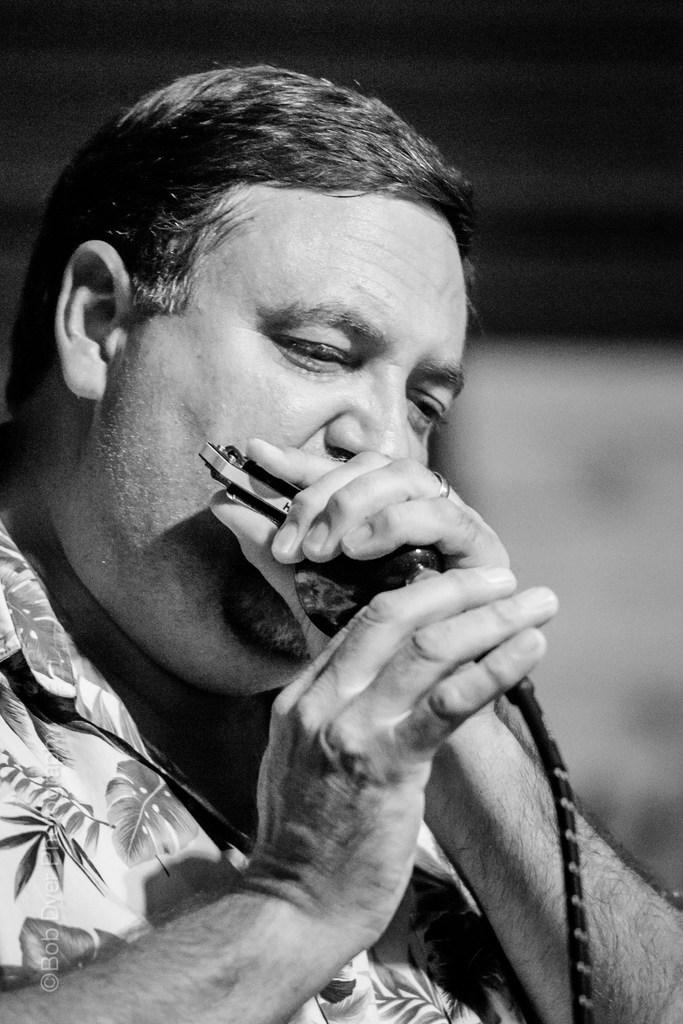What is the color scheme of the image? The image is black and white. Can you describe the main subject of the image? There is a person in the image. What is the person doing in the image? The person is playing a musical instrument with their mouth. What scientific discovery is being made in the image? There is no scientific discovery being made in the image; it simply shows a person playing a musical instrument with their mouth. What day of the week is depicted in the image? The image does not depict a specific day of the week; it is a black and white photograph of a person playing a musical instrument. 